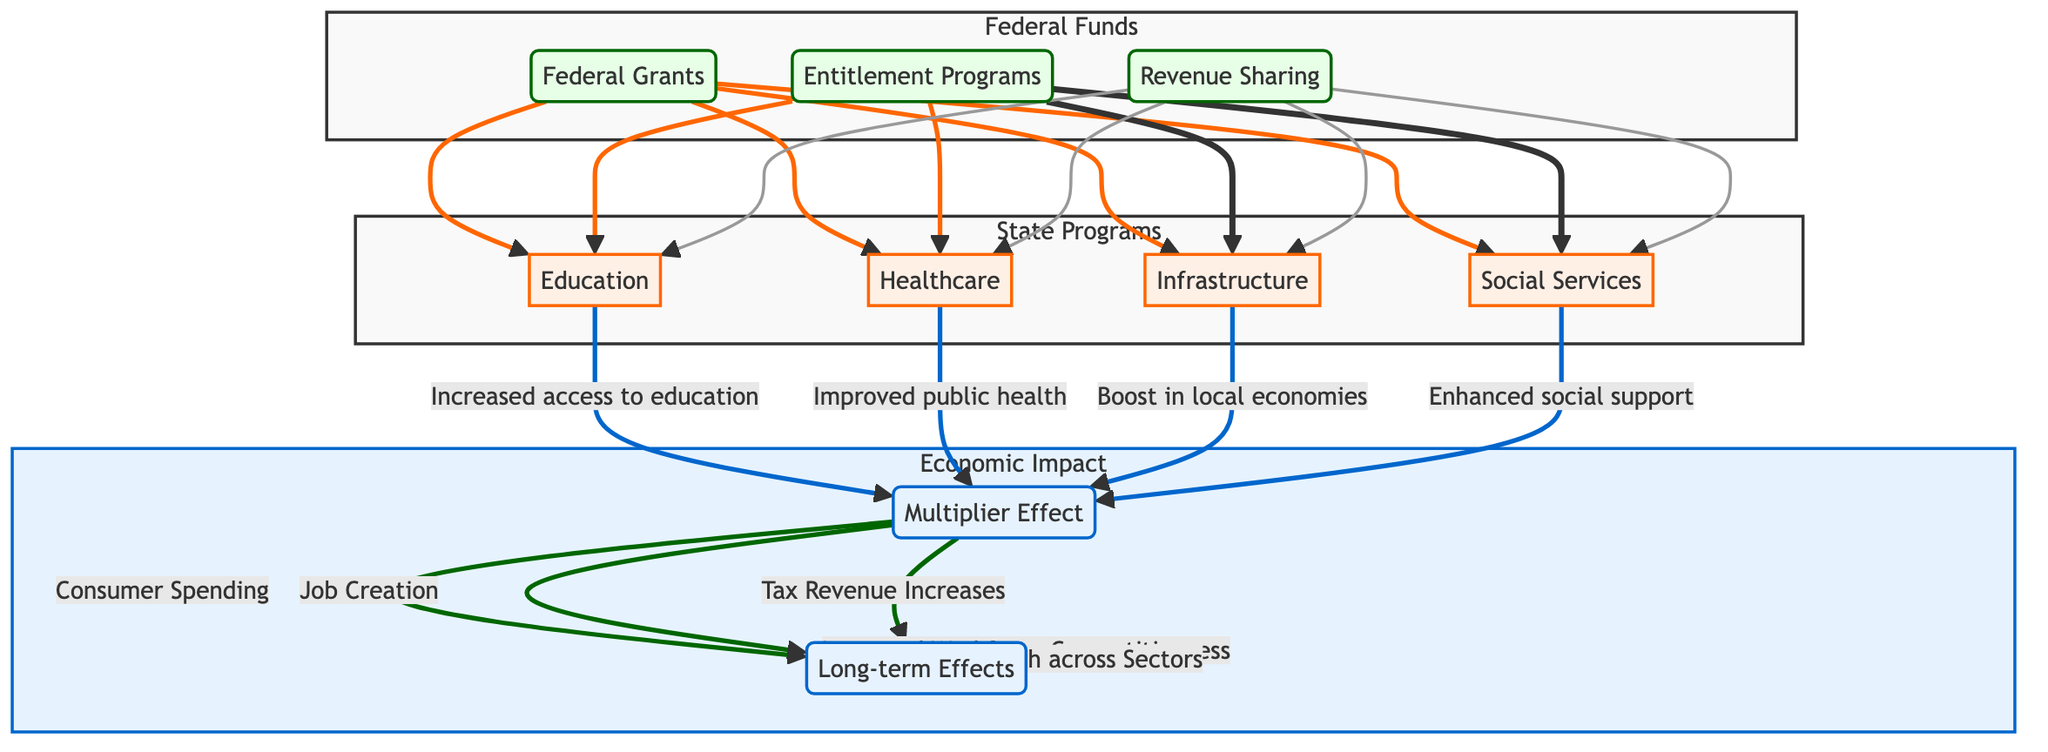What are the three sources of Federal Funds? The diagram lists three sources under the Federal Funds node: Federal Grants, Entitlement Programs, and Revenue Sharing. These are explicitly mentioned and represent the ways through which federal funds are allocated to state programs.
Answer: Federal Grants, Entitlement Programs, Revenue Sharing Which State Program is linked to Healthcare? The diagram shows a direct link from the Healthcare node to the Multiplier Effect node, indicating that improvements in public health metrics, due to funding received, contribute to the broader economic impact represented by the Multiplier Effect.
Answer: Healthcare How many types of Economic Impacts are identified? The diagram delineates two main types of long-term effects stemming from the Multiplier Effect: Improved Workforce Competitiveness and Economic Growth across Sectors. Counting these provides the total types of identified economic impacts.
Answer: 2 What is the impact of the Infrastructure program? The diagram specifies that the Infrastructure program has an impact of boosting local economies and creating jobs through construction projects. This is connected to the Multiplier Effect as an outcome of federal funding.
Answer: Boost in local economies and job creation What do the Federal Grants, Entitlement Programs, and Revenue Sharing all contribute to? The diagram indicates that all three sources of Federal Funds (Federal Grants, Entitlement Programs, and Revenue Sharing) contribute to all four State Programs (Education, Healthcare, Infrastructure, and Social Services). This direct linkage illustrates their collective role in funding state initiatives.
Answer: Education, Healthcare, Infrastructure, Social Services How does the Multiplier Effect relate to Tax Revenue Increases? According to the diagram, the Multiplier Effect leads to increased local spending, which in turn contributes to several outcomes, including Tax Revenue Increases. This illustrates a cause-and-effect relationship in the flow of economic impact.
Answer: Tax Revenue Increases What is the role of Formula-based and project-based funding in Federal Funds allocation? The diagram indicates that the allocation of Federal Funds to State Programs is accomplished through both Formula-based and project-based funding. This step identifies how federal resources are distributed among the programs.
Answer: Formula-based and project-based funding What long-term effect is associated with the Multiplier Effect? The diagram lists at least two long-term effects that emerge from the Multiplier Effect: Improved Workforce Competitiveness and Economic Growth across Sectors. These highlights the broader implications of local economic stimulation.
Answer: Improved Workforce Competitiveness, Economic Growth across Sectors 